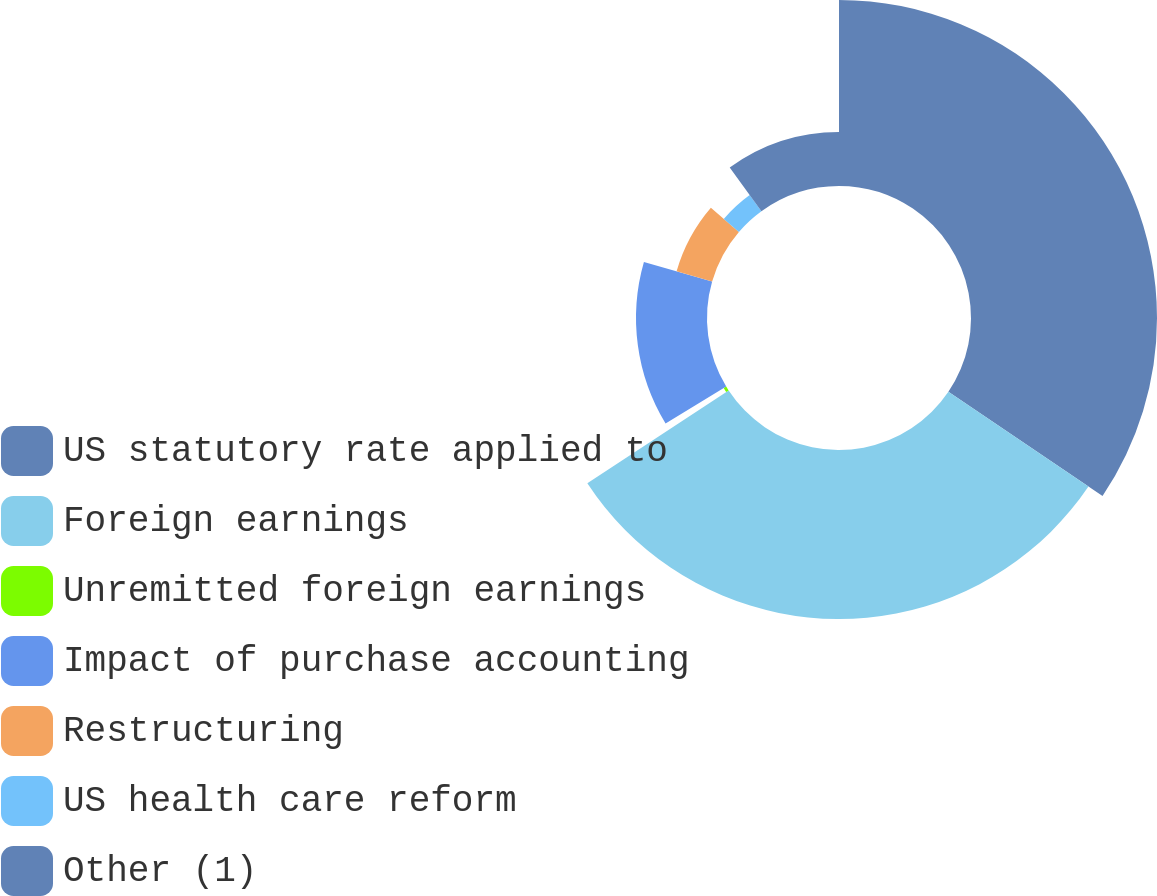<chart> <loc_0><loc_0><loc_500><loc_500><pie_chart><fcel>US statutory rate applied to<fcel>Foreign earnings<fcel>Unremitted foreign earnings<fcel>Impact of purchase accounting<fcel>Restructuring<fcel>US health care reform<fcel>Other (1)<nl><fcel>34.46%<fcel>31.31%<fcel>0.55%<fcel>13.15%<fcel>6.85%<fcel>3.7%<fcel>10.0%<nl></chart> 